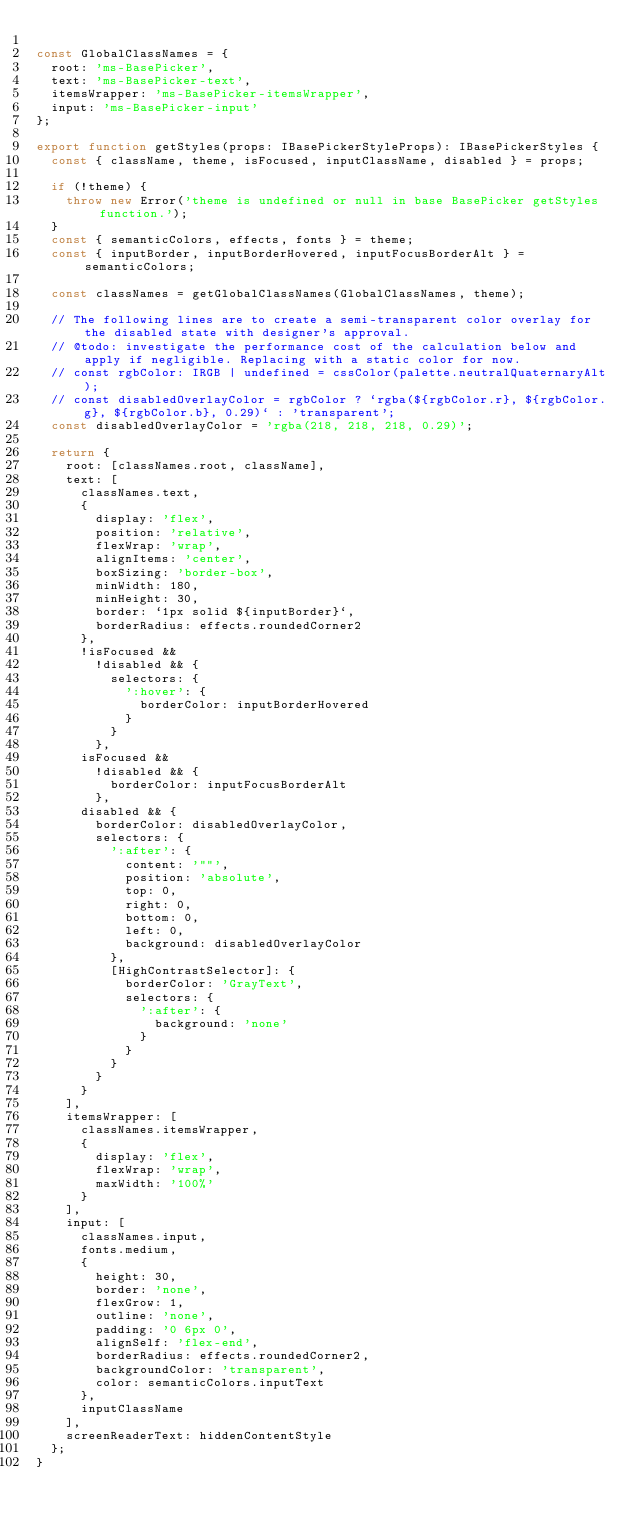<code> <loc_0><loc_0><loc_500><loc_500><_TypeScript_>
const GlobalClassNames = {
  root: 'ms-BasePicker',
  text: 'ms-BasePicker-text',
  itemsWrapper: 'ms-BasePicker-itemsWrapper',
  input: 'ms-BasePicker-input'
};

export function getStyles(props: IBasePickerStyleProps): IBasePickerStyles {
  const { className, theme, isFocused, inputClassName, disabled } = props;

  if (!theme) {
    throw new Error('theme is undefined or null in base BasePicker getStyles function.');
  }
  const { semanticColors, effects, fonts } = theme;
  const { inputBorder, inputBorderHovered, inputFocusBorderAlt } = semanticColors;

  const classNames = getGlobalClassNames(GlobalClassNames, theme);

  // The following lines are to create a semi-transparent color overlay for the disabled state with designer's approval.
  // @todo: investigate the performance cost of the calculation below and apply if negligible. Replacing with a static color for now.
  // const rgbColor: IRGB | undefined = cssColor(palette.neutralQuaternaryAlt);
  // const disabledOverlayColor = rgbColor ? `rgba(${rgbColor.r}, ${rgbColor.g}, ${rgbColor.b}, 0.29)` : 'transparent';
  const disabledOverlayColor = 'rgba(218, 218, 218, 0.29)';

  return {
    root: [classNames.root, className],
    text: [
      classNames.text,
      {
        display: 'flex',
        position: 'relative',
        flexWrap: 'wrap',
        alignItems: 'center',
        boxSizing: 'border-box',
        minWidth: 180,
        minHeight: 30,
        border: `1px solid ${inputBorder}`,
        borderRadius: effects.roundedCorner2
      },
      !isFocused &&
        !disabled && {
          selectors: {
            ':hover': {
              borderColor: inputBorderHovered
            }
          }
        },
      isFocused &&
        !disabled && {
          borderColor: inputFocusBorderAlt
        },
      disabled && {
        borderColor: disabledOverlayColor,
        selectors: {
          ':after': {
            content: '""',
            position: 'absolute',
            top: 0,
            right: 0,
            bottom: 0,
            left: 0,
            background: disabledOverlayColor
          },
          [HighContrastSelector]: {
            borderColor: 'GrayText',
            selectors: {
              ':after': {
                background: 'none'
              }
            }
          }
        }
      }
    ],
    itemsWrapper: [
      classNames.itemsWrapper,
      {
        display: 'flex',
        flexWrap: 'wrap',
        maxWidth: '100%'
      }
    ],
    input: [
      classNames.input,
      fonts.medium,
      {
        height: 30,
        border: 'none',
        flexGrow: 1,
        outline: 'none',
        padding: '0 6px 0',
        alignSelf: 'flex-end',
        borderRadius: effects.roundedCorner2,
        backgroundColor: 'transparent',
        color: semanticColors.inputText
      },
      inputClassName
    ],
    screenReaderText: hiddenContentStyle
  };
}
</code> 